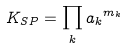<formula> <loc_0><loc_0><loc_500><loc_500>K _ { S P } = \prod _ { k } { a _ { k } } ^ { m _ { k } }</formula> 